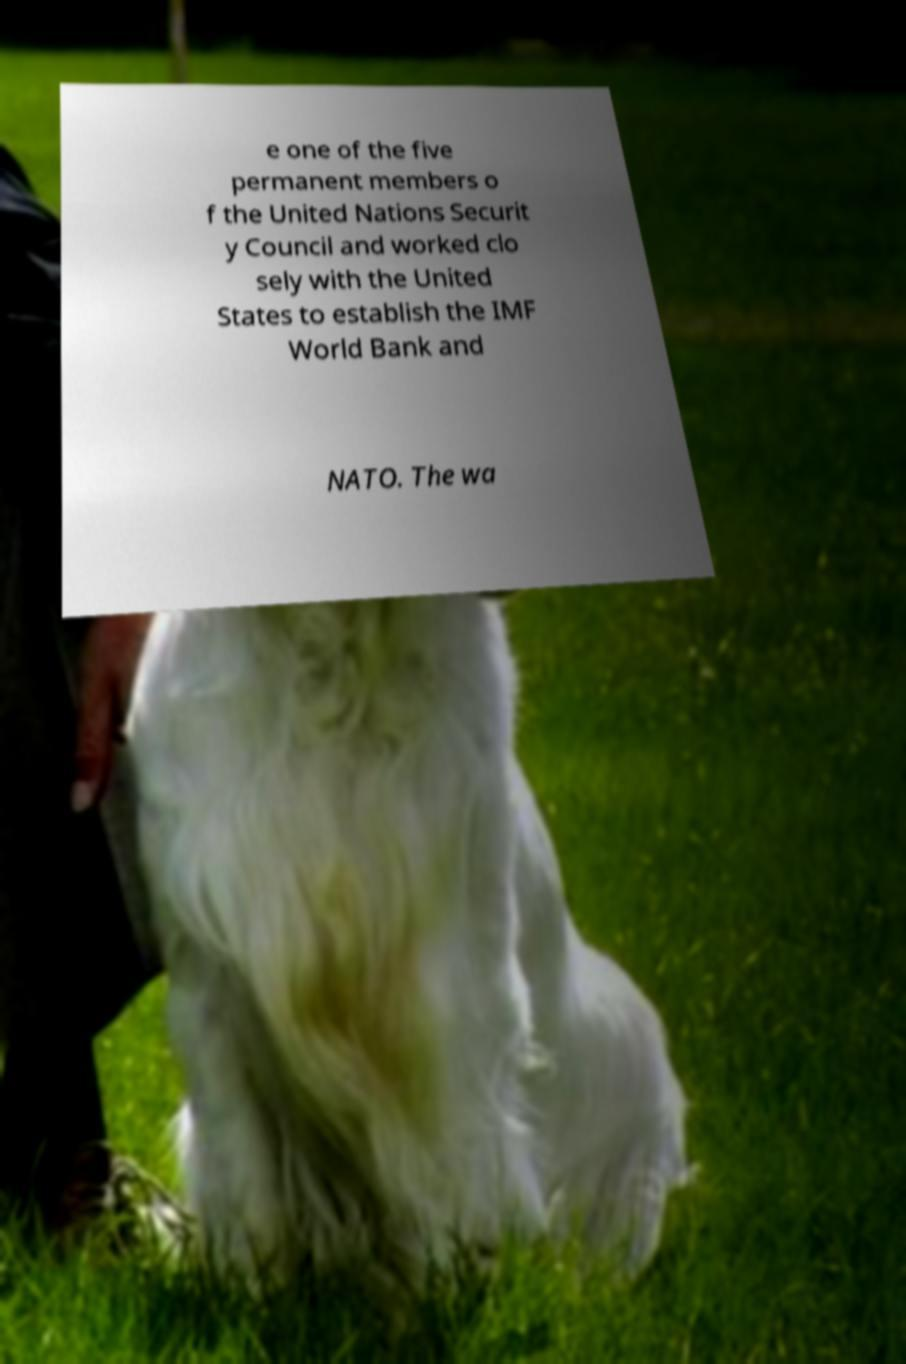Can you accurately transcribe the text from the provided image for me? e one of the five permanent members o f the United Nations Securit y Council and worked clo sely with the United States to establish the IMF World Bank and NATO. The wa 